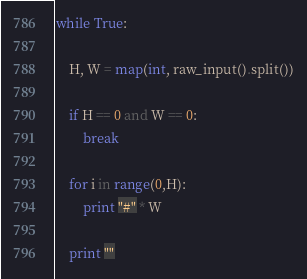<code> <loc_0><loc_0><loc_500><loc_500><_Python_>while True:
    
    H, W = map(int, raw_input().split())
	
    if H == 0 and W == 0:
    	break

    for i in range(0,H):
        print "#" * W

    print ""</code> 